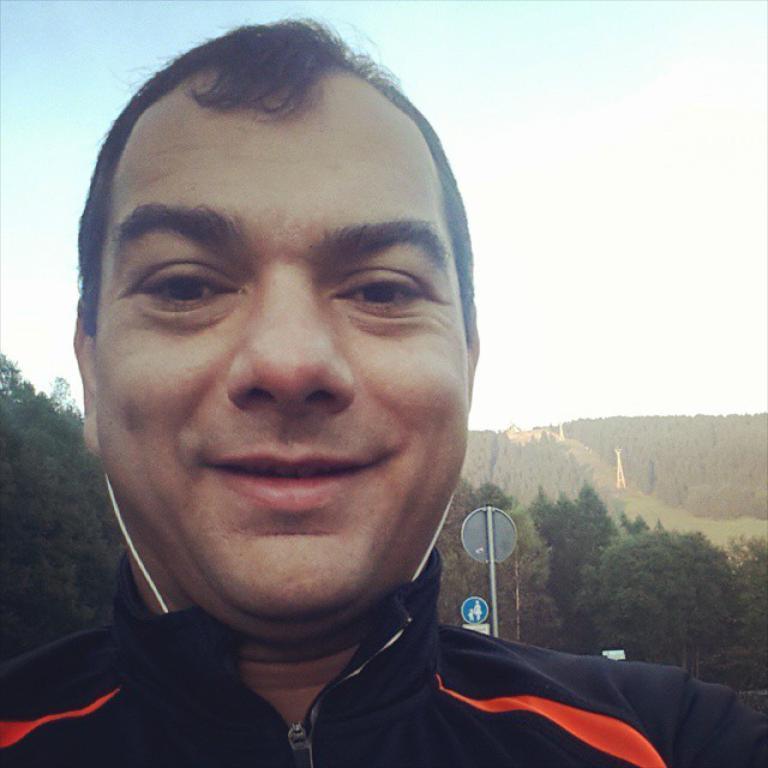Describe this image in one or two sentences. In this image there is the sky towards the top of the image, there are trees, there are objects that looks like a tower, there is a pole, there are boards, there is a man towards the bottom of the image, there is a wire. 